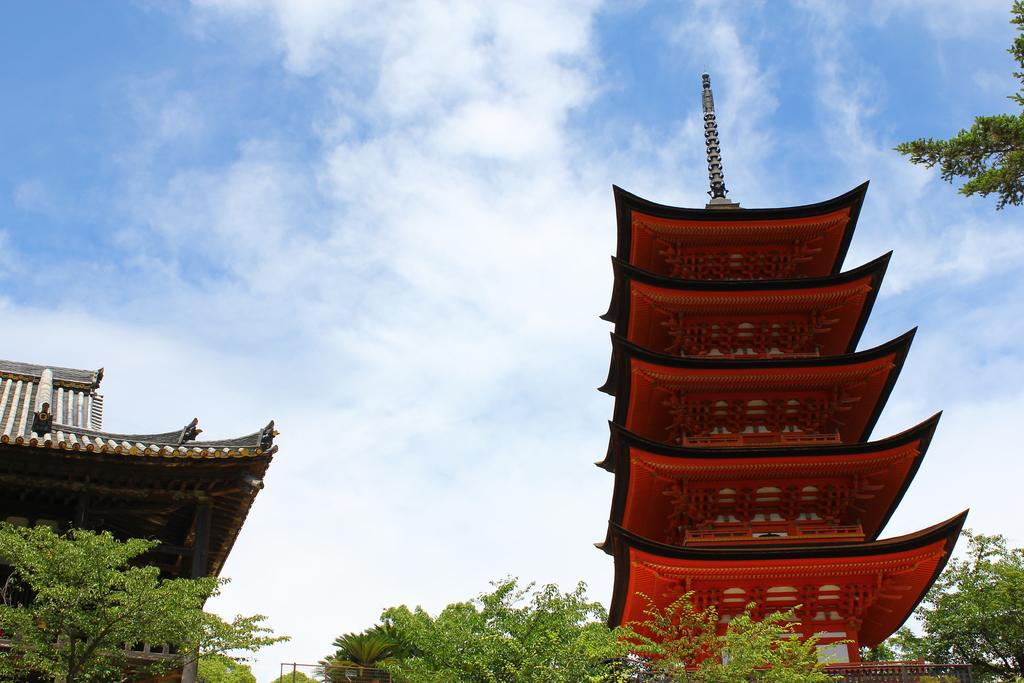What type of natural elements can be seen in the image? There are trees in the image. What type of man-made structures are present in the image? There are buildings in the image. Where are the trees and buildings located in the image? The trees and buildings are at the bottom of the image. What can be seen in the background of the image? The sky is visible in the background of the image. What type of dress is hanging from the tree in the image? There is no dress hanging from the tree in the image; only trees and buildings are present. 